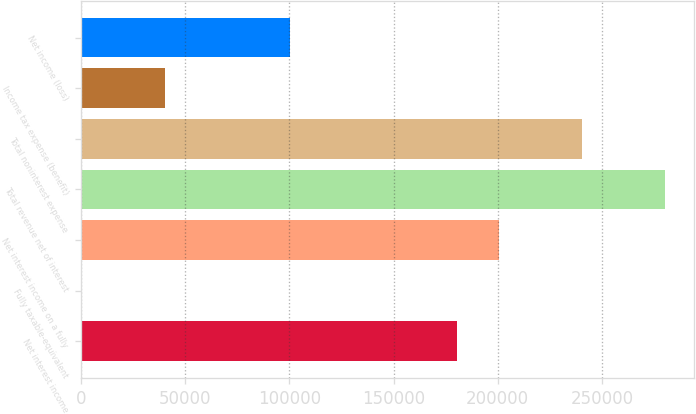Convert chart to OTSL. <chart><loc_0><loc_0><loc_500><loc_500><bar_chart><fcel>Net interest income<fcel>Fully taxable-equivalent<fcel>Net interest income on a fully<fcel>Total revenue net of interest<fcel>Total noninterest expense<fcel>Income tax expense (benefit)<fcel>Net income (loss)<nl><fcel>180374<fcel>321<fcel>200380<fcel>280404<fcel>240392<fcel>40332.8<fcel>100350<nl></chart> 